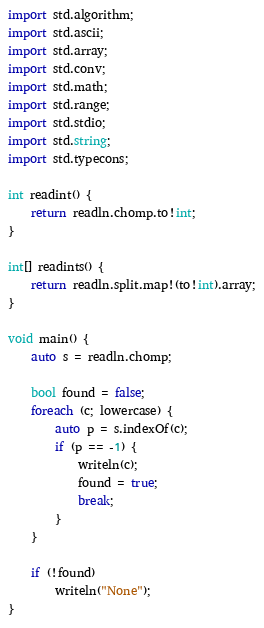Convert code to text. <code><loc_0><loc_0><loc_500><loc_500><_D_>import std.algorithm;
import std.ascii;
import std.array;
import std.conv;
import std.math;
import std.range;
import std.stdio;
import std.string;
import std.typecons;

int readint() {
    return readln.chomp.to!int;
}

int[] readints() {
    return readln.split.map!(to!int).array;
}

void main() {
    auto s = readln.chomp;

    bool found = false;
    foreach (c; lowercase) {
        auto p = s.indexOf(c);
        if (p == -1) {
            writeln(c);
            found = true;
            break;
        }
    }

    if (!found)
        writeln("None");
}
</code> 